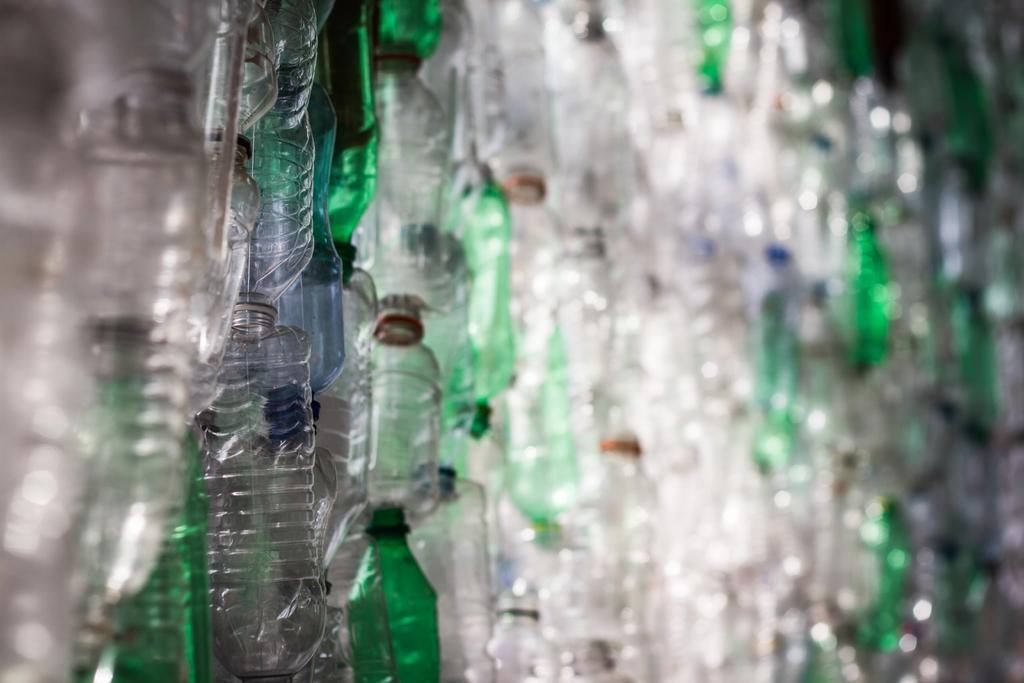Describe this image in one or two sentences. In this image i can see few bottles. 